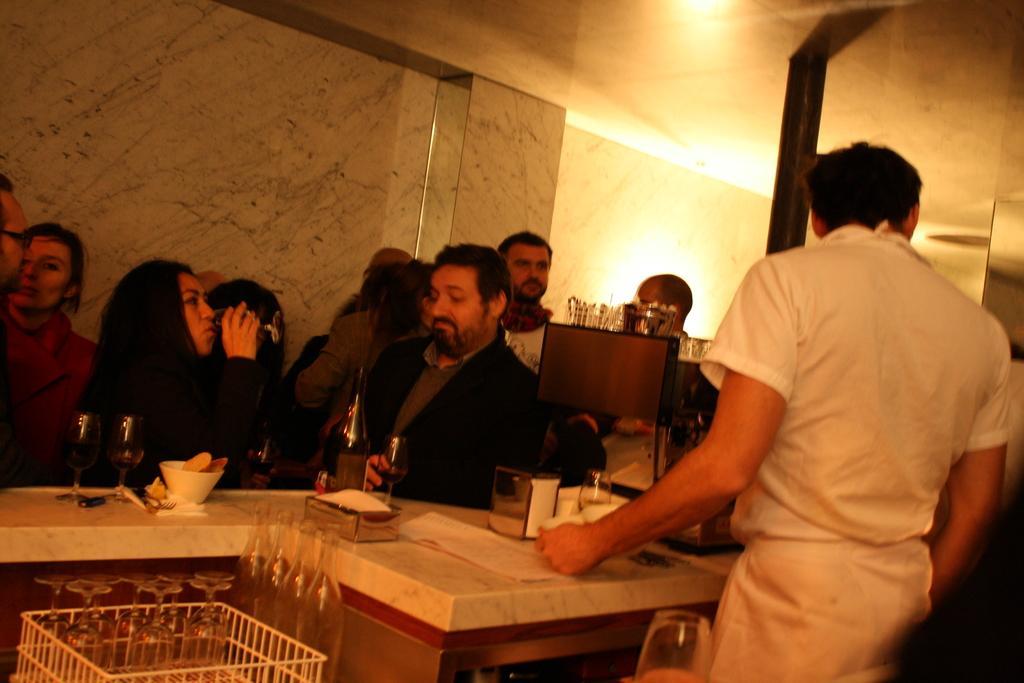Could you give a brief overview of what you see in this image? In the middle there is a man he wear suit. On the right there is a man he wear white shirt. On the left there is a woman she is drinking something. In the background there are many people ,wall and light. 